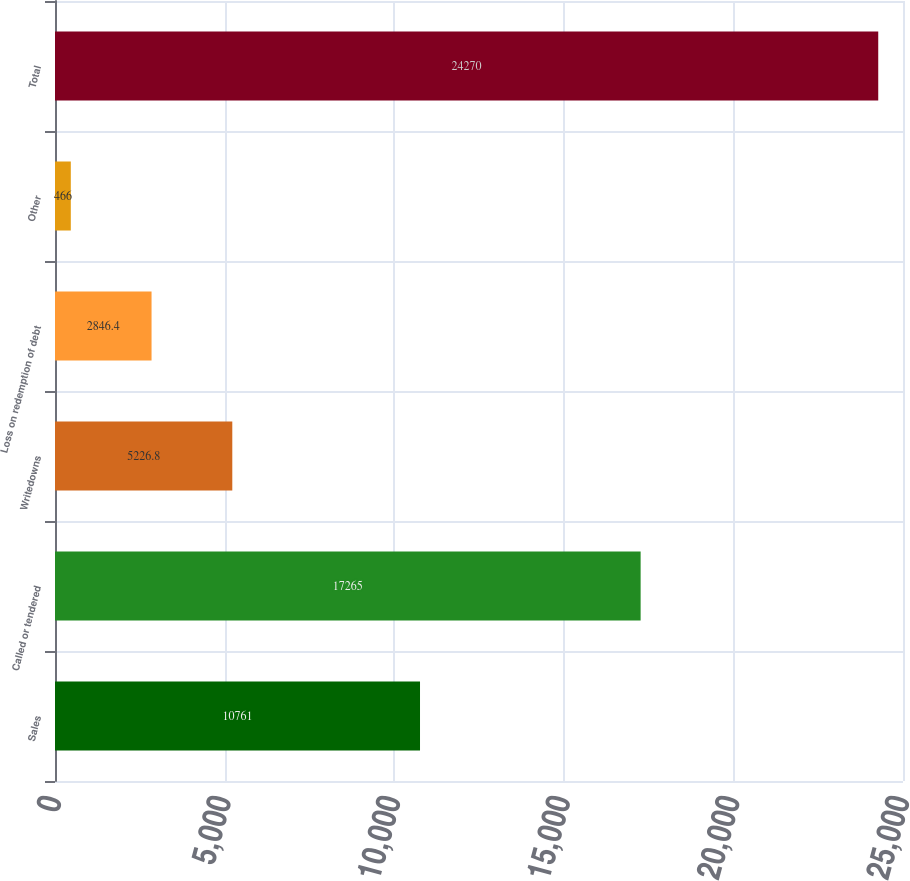<chart> <loc_0><loc_0><loc_500><loc_500><bar_chart><fcel>Sales<fcel>Called or tendered<fcel>Writedowns<fcel>Loss on redemption of debt<fcel>Other<fcel>Total<nl><fcel>10761<fcel>17265<fcel>5226.8<fcel>2846.4<fcel>466<fcel>24270<nl></chart> 